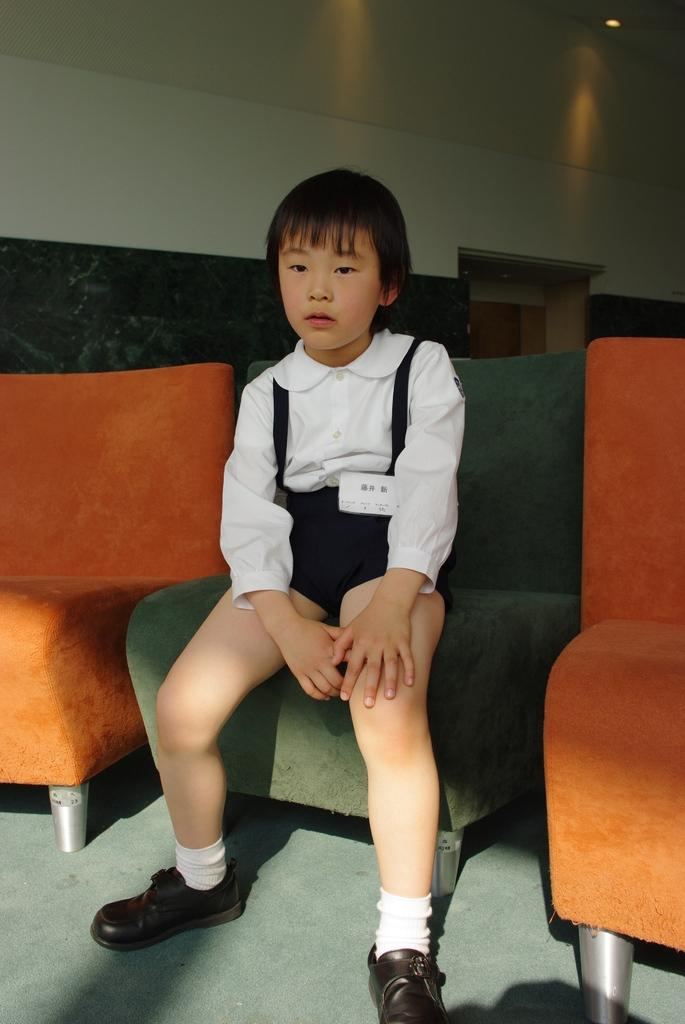What type of furniture is present in the image? There are chairs in the image. What is the kid doing while sitting on the chairs? A kid is sitting on the chairs. What can be seen at the top of the image? There are lights on the top of the image. What is the girl wearing in the image? The girl is wearing a black and white dress. What type of map is the girl holding in the image? There is no map present in the image. What reward is the girl receiving for her degree in the image? There is no mention of a degree or reward in the image. 